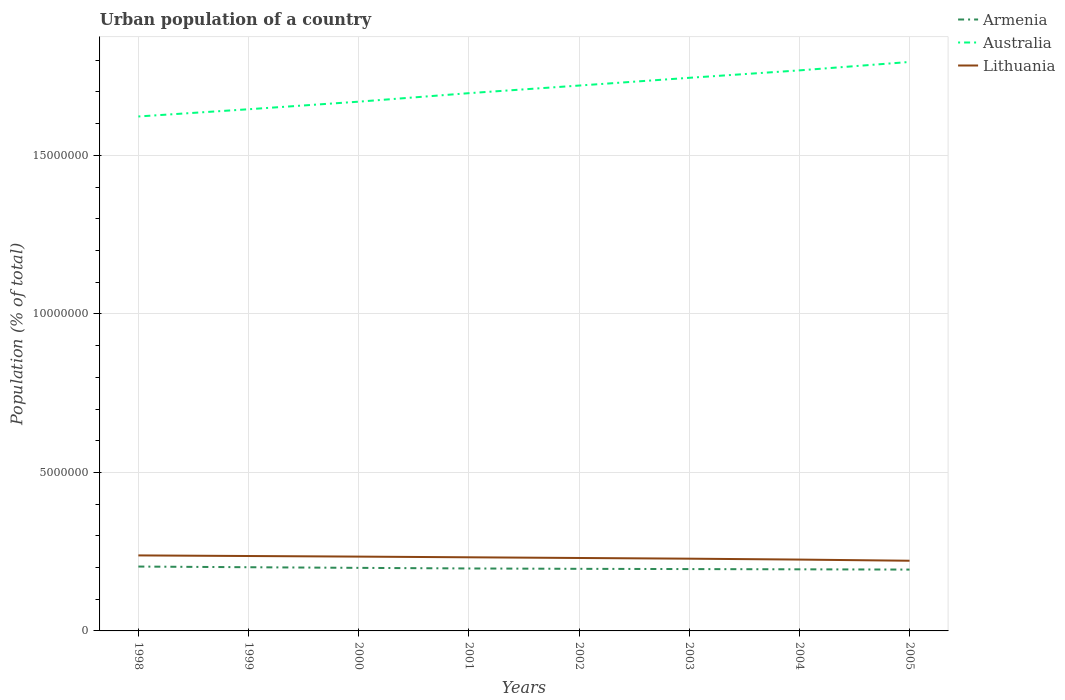Does the line corresponding to Australia intersect with the line corresponding to Armenia?
Keep it short and to the point. No. Is the number of lines equal to the number of legend labels?
Keep it short and to the point. Yes. Across all years, what is the maximum urban population in Armenia?
Offer a terse response. 1.94e+06. What is the total urban population in Lithuania in the graph?
Keep it short and to the point. 4.33e+04. What is the difference between the highest and the second highest urban population in Australia?
Offer a terse response. 1.72e+06. Is the urban population in Armenia strictly greater than the urban population in Lithuania over the years?
Ensure brevity in your answer.  Yes. How many lines are there?
Keep it short and to the point. 3. How many years are there in the graph?
Provide a succinct answer. 8. What is the difference between two consecutive major ticks on the Y-axis?
Provide a succinct answer. 5.00e+06. Where does the legend appear in the graph?
Offer a terse response. Top right. What is the title of the graph?
Keep it short and to the point. Urban population of a country. What is the label or title of the X-axis?
Make the answer very short. Years. What is the label or title of the Y-axis?
Give a very brief answer. Population (% of total). What is the Population (% of total) of Armenia in 1998?
Ensure brevity in your answer.  2.03e+06. What is the Population (% of total) of Australia in 1998?
Offer a very short reply. 1.62e+07. What is the Population (% of total) of Lithuania in 1998?
Ensure brevity in your answer.  2.38e+06. What is the Population (% of total) of Armenia in 1999?
Make the answer very short. 2.01e+06. What is the Population (% of total) in Australia in 1999?
Provide a succinct answer. 1.65e+07. What is the Population (% of total) of Lithuania in 1999?
Your response must be concise. 2.36e+06. What is the Population (% of total) of Armenia in 2000?
Give a very brief answer. 1.99e+06. What is the Population (% of total) of Australia in 2000?
Give a very brief answer. 1.67e+07. What is the Population (% of total) in Lithuania in 2000?
Offer a very short reply. 2.34e+06. What is the Population (% of total) of Armenia in 2001?
Make the answer very short. 1.97e+06. What is the Population (% of total) of Australia in 2001?
Make the answer very short. 1.70e+07. What is the Population (% of total) of Lithuania in 2001?
Your response must be concise. 2.32e+06. What is the Population (% of total) of Armenia in 2002?
Your response must be concise. 1.96e+06. What is the Population (% of total) in Australia in 2002?
Your answer should be very brief. 1.72e+07. What is the Population (% of total) of Lithuania in 2002?
Provide a short and direct response. 2.30e+06. What is the Population (% of total) in Armenia in 2003?
Your answer should be very brief. 1.95e+06. What is the Population (% of total) of Australia in 2003?
Your response must be concise. 1.74e+07. What is the Population (% of total) of Lithuania in 2003?
Your response must be concise. 2.28e+06. What is the Population (% of total) of Armenia in 2004?
Your response must be concise. 1.94e+06. What is the Population (% of total) in Australia in 2004?
Provide a short and direct response. 1.77e+07. What is the Population (% of total) of Lithuania in 2004?
Your response must be concise. 2.25e+06. What is the Population (% of total) in Armenia in 2005?
Your response must be concise. 1.94e+06. What is the Population (% of total) in Australia in 2005?
Offer a very short reply. 1.79e+07. What is the Population (% of total) of Lithuania in 2005?
Your answer should be very brief. 2.21e+06. Across all years, what is the maximum Population (% of total) of Armenia?
Ensure brevity in your answer.  2.03e+06. Across all years, what is the maximum Population (% of total) in Australia?
Give a very brief answer. 1.79e+07. Across all years, what is the maximum Population (% of total) of Lithuania?
Your response must be concise. 2.38e+06. Across all years, what is the minimum Population (% of total) of Armenia?
Keep it short and to the point. 1.94e+06. Across all years, what is the minimum Population (% of total) in Australia?
Your answer should be very brief. 1.62e+07. Across all years, what is the minimum Population (% of total) in Lithuania?
Keep it short and to the point. 2.21e+06. What is the total Population (% of total) of Armenia in the graph?
Give a very brief answer. 1.58e+07. What is the total Population (% of total) in Australia in the graph?
Your answer should be compact. 1.37e+08. What is the total Population (% of total) in Lithuania in the graph?
Your answer should be very brief. 1.85e+07. What is the difference between the Population (% of total) in Armenia in 1998 and that in 1999?
Provide a succinct answer. 2.11e+04. What is the difference between the Population (% of total) in Australia in 1998 and that in 1999?
Provide a short and direct response. -2.28e+05. What is the difference between the Population (% of total) of Lithuania in 1998 and that in 1999?
Your answer should be compact. 1.90e+04. What is the difference between the Population (% of total) of Armenia in 1998 and that in 2000?
Your answer should be very brief. 4.13e+04. What is the difference between the Population (% of total) in Australia in 1998 and that in 2000?
Offer a very short reply. -4.67e+05. What is the difference between the Population (% of total) in Lithuania in 1998 and that in 2000?
Keep it short and to the point. 3.76e+04. What is the difference between the Population (% of total) of Armenia in 1998 and that in 2001?
Ensure brevity in your answer.  6.03e+04. What is the difference between the Population (% of total) of Australia in 1998 and that in 2001?
Offer a very short reply. -7.35e+05. What is the difference between the Population (% of total) in Lithuania in 1998 and that in 2001?
Your answer should be very brief. 5.92e+04. What is the difference between the Population (% of total) of Armenia in 1998 and that in 2002?
Ensure brevity in your answer.  7.16e+04. What is the difference between the Population (% of total) in Australia in 1998 and that in 2002?
Give a very brief answer. -9.76e+05. What is the difference between the Population (% of total) in Lithuania in 1998 and that in 2002?
Your response must be concise. 8.09e+04. What is the difference between the Population (% of total) of Armenia in 1998 and that in 2003?
Provide a short and direct response. 7.96e+04. What is the difference between the Population (% of total) in Australia in 1998 and that in 2003?
Make the answer very short. -1.22e+06. What is the difference between the Population (% of total) in Lithuania in 1998 and that in 2003?
Your response must be concise. 1.03e+05. What is the difference between the Population (% of total) of Armenia in 1998 and that in 2004?
Provide a succinct answer. 8.73e+04. What is the difference between the Population (% of total) of Australia in 1998 and that in 2004?
Provide a succinct answer. -1.45e+06. What is the difference between the Population (% of total) in Lithuania in 1998 and that in 2004?
Your answer should be very brief. 1.31e+05. What is the difference between the Population (% of total) of Armenia in 1998 and that in 2005?
Your answer should be very brief. 9.54e+04. What is the difference between the Population (% of total) of Australia in 1998 and that in 2005?
Provide a succinct answer. -1.72e+06. What is the difference between the Population (% of total) in Lithuania in 1998 and that in 2005?
Give a very brief answer. 1.68e+05. What is the difference between the Population (% of total) in Armenia in 1999 and that in 2000?
Keep it short and to the point. 2.02e+04. What is the difference between the Population (% of total) of Australia in 1999 and that in 2000?
Your answer should be compact. -2.39e+05. What is the difference between the Population (% of total) in Lithuania in 1999 and that in 2000?
Your response must be concise. 1.87e+04. What is the difference between the Population (% of total) in Armenia in 1999 and that in 2001?
Provide a short and direct response. 3.91e+04. What is the difference between the Population (% of total) in Australia in 1999 and that in 2001?
Provide a succinct answer. -5.07e+05. What is the difference between the Population (% of total) of Lithuania in 1999 and that in 2001?
Give a very brief answer. 4.02e+04. What is the difference between the Population (% of total) in Armenia in 1999 and that in 2002?
Ensure brevity in your answer.  5.05e+04. What is the difference between the Population (% of total) of Australia in 1999 and that in 2002?
Make the answer very short. -7.47e+05. What is the difference between the Population (% of total) of Lithuania in 1999 and that in 2002?
Ensure brevity in your answer.  6.19e+04. What is the difference between the Population (% of total) of Armenia in 1999 and that in 2003?
Make the answer very short. 5.84e+04. What is the difference between the Population (% of total) of Australia in 1999 and that in 2003?
Keep it short and to the point. -9.92e+05. What is the difference between the Population (% of total) of Lithuania in 1999 and that in 2003?
Your response must be concise. 8.36e+04. What is the difference between the Population (% of total) of Armenia in 1999 and that in 2004?
Provide a short and direct response. 6.61e+04. What is the difference between the Population (% of total) of Australia in 1999 and that in 2004?
Ensure brevity in your answer.  -1.23e+06. What is the difference between the Population (% of total) of Lithuania in 1999 and that in 2004?
Offer a very short reply. 1.12e+05. What is the difference between the Population (% of total) of Armenia in 1999 and that in 2005?
Make the answer very short. 7.42e+04. What is the difference between the Population (% of total) of Australia in 1999 and that in 2005?
Ensure brevity in your answer.  -1.49e+06. What is the difference between the Population (% of total) of Lithuania in 1999 and that in 2005?
Your response must be concise. 1.49e+05. What is the difference between the Population (% of total) in Armenia in 2000 and that in 2001?
Give a very brief answer. 1.90e+04. What is the difference between the Population (% of total) in Australia in 2000 and that in 2001?
Offer a terse response. -2.68e+05. What is the difference between the Population (% of total) of Lithuania in 2000 and that in 2001?
Ensure brevity in your answer.  2.16e+04. What is the difference between the Population (% of total) of Armenia in 2000 and that in 2002?
Keep it short and to the point. 3.03e+04. What is the difference between the Population (% of total) in Australia in 2000 and that in 2002?
Your answer should be compact. -5.08e+05. What is the difference between the Population (% of total) of Lithuania in 2000 and that in 2002?
Your response must be concise. 4.33e+04. What is the difference between the Population (% of total) in Armenia in 2000 and that in 2003?
Keep it short and to the point. 3.83e+04. What is the difference between the Population (% of total) of Australia in 2000 and that in 2003?
Offer a very short reply. -7.53e+05. What is the difference between the Population (% of total) in Lithuania in 2000 and that in 2003?
Make the answer very short. 6.50e+04. What is the difference between the Population (% of total) in Armenia in 2000 and that in 2004?
Offer a very short reply. 4.60e+04. What is the difference between the Population (% of total) of Australia in 2000 and that in 2004?
Keep it short and to the point. -9.87e+05. What is the difference between the Population (% of total) in Lithuania in 2000 and that in 2004?
Make the answer very short. 9.35e+04. What is the difference between the Population (% of total) of Armenia in 2000 and that in 2005?
Make the answer very short. 5.41e+04. What is the difference between the Population (% of total) in Australia in 2000 and that in 2005?
Give a very brief answer. -1.25e+06. What is the difference between the Population (% of total) in Lithuania in 2000 and that in 2005?
Make the answer very short. 1.30e+05. What is the difference between the Population (% of total) in Armenia in 2001 and that in 2002?
Provide a short and direct response. 1.13e+04. What is the difference between the Population (% of total) of Australia in 2001 and that in 2002?
Your answer should be compact. -2.40e+05. What is the difference between the Population (% of total) in Lithuania in 2001 and that in 2002?
Your answer should be very brief. 2.17e+04. What is the difference between the Population (% of total) of Armenia in 2001 and that in 2003?
Provide a succinct answer. 1.93e+04. What is the difference between the Population (% of total) in Australia in 2001 and that in 2003?
Your answer should be compact. -4.85e+05. What is the difference between the Population (% of total) of Lithuania in 2001 and that in 2003?
Your response must be concise. 4.34e+04. What is the difference between the Population (% of total) of Armenia in 2001 and that in 2004?
Ensure brevity in your answer.  2.70e+04. What is the difference between the Population (% of total) in Australia in 2001 and that in 2004?
Your answer should be very brief. -7.19e+05. What is the difference between the Population (% of total) of Lithuania in 2001 and that in 2004?
Make the answer very short. 7.20e+04. What is the difference between the Population (% of total) in Armenia in 2001 and that in 2005?
Your answer should be compact. 3.51e+04. What is the difference between the Population (% of total) of Australia in 2001 and that in 2005?
Make the answer very short. -9.85e+05. What is the difference between the Population (% of total) of Lithuania in 2001 and that in 2005?
Keep it short and to the point. 1.09e+05. What is the difference between the Population (% of total) of Armenia in 2002 and that in 2003?
Provide a succinct answer. 7963. What is the difference between the Population (% of total) in Australia in 2002 and that in 2003?
Provide a succinct answer. -2.44e+05. What is the difference between the Population (% of total) in Lithuania in 2002 and that in 2003?
Offer a terse response. 2.17e+04. What is the difference between the Population (% of total) of Armenia in 2002 and that in 2004?
Offer a very short reply. 1.57e+04. What is the difference between the Population (% of total) of Australia in 2002 and that in 2004?
Make the answer very short. -4.79e+05. What is the difference between the Population (% of total) of Lithuania in 2002 and that in 2004?
Ensure brevity in your answer.  5.02e+04. What is the difference between the Population (% of total) in Armenia in 2002 and that in 2005?
Offer a terse response. 2.38e+04. What is the difference between the Population (% of total) in Australia in 2002 and that in 2005?
Keep it short and to the point. -7.44e+05. What is the difference between the Population (% of total) in Lithuania in 2002 and that in 2005?
Offer a very short reply. 8.70e+04. What is the difference between the Population (% of total) of Armenia in 2003 and that in 2004?
Ensure brevity in your answer.  7705. What is the difference between the Population (% of total) of Australia in 2003 and that in 2004?
Your answer should be very brief. -2.34e+05. What is the difference between the Population (% of total) in Lithuania in 2003 and that in 2004?
Make the answer very short. 2.85e+04. What is the difference between the Population (% of total) in Armenia in 2003 and that in 2005?
Your response must be concise. 1.58e+04. What is the difference between the Population (% of total) of Australia in 2003 and that in 2005?
Your response must be concise. -5.00e+05. What is the difference between the Population (% of total) in Lithuania in 2003 and that in 2005?
Give a very brief answer. 6.52e+04. What is the difference between the Population (% of total) in Armenia in 2004 and that in 2005?
Your answer should be compact. 8101. What is the difference between the Population (% of total) in Australia in 2004 and that in 2005?
Offer a terse response. -2.66e+05. What is the difference between the Population (% of total) of Lithuania in 2004 and that in 2005?
Keep it short and to the point. 3.67e+04. What is the difference between the Population (% of total) in Armenia in 1998 and the Population (% of total) in Australia in 1999?
Provide a succinct answer. -1.44e+07. What is the difference between the Population (% of total) of Armenia in 1998 and the Population (% of total) of Lithuania in 1999?
Ensure brevity in your answer.  -3.32e+05. What is the difference between the Population (% of total) in Australia in 1998 and the Population (% of total) in Lithuania in 1999?
Your answer should be compact. 1.39e+07. What is the difference between the Population (% of total) of Armenia in 1998 and the Population (% of total) of Australia in 2000?
Offer a terse response. -1.47e+07. What is the difference between the Population (% of total) in Armenia in 1998 and the Population (% of total) in Lithuania in 2000?
Make the answer very short. -3.14e+05. What is the difference between the Population (% of total) of Australia in 1998 and the Population (% of total) of Lithuania in 2000?
Keep it short and to the point. 1.39e+07. What is the difference between the Population (% of total) of Armenia in 1998 and the Population (% of total) of Australia in 2001?
Offer a terse response. -1.49e+07. What is the difference between the Population (% of total) in Armenia in 1998 and the Population (% of total) in Lithuania in 2001?
Provide a short and direct response. -2.92e+05. What is the difference between the Population (% of total) in Australia in 1998 and the Population (% of total) in Lithuania in 2001?
Your answer should be compact. 1.39e+07. What is the difference between the Population (% of total) in Armenia in 1998 and the Population (% of total) in Australia in 2002?
Make the answer very short. -1.52e+07. What is the difference between the Population (% of total) of Armenia in 1998 and the Population (% of total) of Lithuania in 2002?
Your response must be concise. -2.70e+05. What is the difference between the Population (% of total) of Australia in 1998 and the Population (% of total) of Lithuania in 2002?
Ensure brevity in your answer.  1.39e+07. What is the difference between the Population (% of total) in Armenia in 1998 and the Population (% of total) in Australia in 2003?
Your answer should be very brief. -1.54e+07. What is the difference between the Population (% of total) of Armenia in 1998 and the Population (% of total) of Lithuania in 2003?
Keep it short and to the point. -2.49e+05. What is the difference between the Population (% of total) of Australia in 1998 and the Population (% of total) of Lithuania in 2003?
Your response must be concise. 1.39e+07. What is the difference between the Population (% of total) of Armenia in 1998 and the Population (% of total) of Australia in 2004?
Your answer should be compact. -1.57e+07. What is the difference between the Population (% of total) in Armenia in 1998 and the Population (% of total) in Lithuania in 2004?
Make the answer very short. -2.20e+05. What is the difference between the Population (% of total) in Australia in 1998 and the Population (% of total) in Lithuania in 2004?
Your answer should be very brief. 1.40e+07. What is the difference between the Population (% of total) in Armenia in 1998 and the Population (% of total) in Australia in 2005?
Provide a short and direct response. -1.59e+07. What is the difference between the Population (% of total) in Armenia in 1998 and the Population (% of total) in Lithuania in 2005?
Offer a terse response. -1.84e+05. What is the difference between the Population (% of total) in Australia in 1998 and the Population (% of total) in Lithuania in 2005?
Provide a short and direct response. 1.40e+07. What is the difference between the Population (% of total) of Armenia in 1999 and the Population (% of total) of Australia in 2000?
Your response must be concise. -1.47e+07. What is the difference between the Population (% of total) of Armenia in 1999 and the Population (% of total) of Lithuania in 2000?
Make the answer very short. -3.35e+05. What is the difference between the Population (% of total) in Australia in 1999 and the Population (% of total) in Lithuania in 2000?
Make the answer very short. 1.41e+07. What is the difference between the Population (% of total) of Armenia in 1999 and the Population (% of total) of Australia in 2001?
Offer a terse response. -1.50e+07. What is the difference between the Population (% of total) of Armenia in 1999 and the Population (% of total) of Lithuania in 2001?
Make the answer very short. -3.13e+05. What is the difference between the Population (% of total) in Australia in 1999 and the Population (% of total) in Lithuania in 2001?
Make the answer very short. 1.41e+07. What is the difference between the Population (% of total) in Armenia in 1999 and the Population (% of total) in Australia in 2002?
Your answer should be very brief. -1.52e+07. What is the difference between the Population (% of total) of Armenia in 1999 and the Population (% of total) of Lithuania in 2002?
Give a very brief answer. -2.92e+05. What is the difference between the Population (% of total) of Australia in 1999 and the Population (% of total) of Lithuania in 2002?
Make the answer very short. 1.42e+07. What is the difference between the Population (% of total) of Armenia in 1999 and the Population (% of total) of Australia in 2003?
Ensure brevity in your answer.  -1.54e+07. What is the difference between the Population (% of total) in Armenia in 1999 and the Population (% of total) in Lithuania in 2003?
Keep it short and to the point. -2.70e+05. What is the difference between the Population (% of total) in Australia in 1999 and the Population (% of total) in Lithuania in 2003?
Your answer should be compact. 1.42e+07. What is the difference between the Population (% of total) of Armenia in 1999 and the Population (% of total) of Australia in 2004?
Your answer should be very brief. -1.57e+07. What is the difference between the Population (% of total) of Armenia in 1999 and the Population (% of total) of Lithuania in 2004?
Provide a short and direct response. -2.41e+05. What is the difference between the Population (% of total) of Australia in 1999 and the Population (% of total) of Lithuania in 2004?
Offer a terse response. 1.42e+07. What is the difference between the Population (% of total) in Armenia in 1999 and the Population (% of total) in Australia in 2005?
Provide a short and direct response. -1.59e+07. What is the difference between the Population (% of total) in Armenia in 1999 and the Population (% of total) in Lithuania in 2005?
Your answer should be very brief. -2.05e+05. What is the difference between the Population (% of total) in Australia in 1999 and the Population (% of total) in Lithuania in 2005?
Offer a very short reply. 1.42e+07. What is the difference between the Population (% of total) in Armenia in 2000 and the Population (% of total) in Australia in 2001?
Give a very brief answer. -1.50e+07. What is the difference between the Population (% of total) in Armenia in 2000 and the Population (% of total) in Lithuania in 2001?
Offer a terse response. -3.33e+05. What is the difference between the Population (% of total) in Australia in 2000 and the Population (% of total) in Lithuania in 2001?
Give a very brief answer. 1.44e+07. What is the difference between the Population (% of total) in Armenia in 2000 and the Population (% of total) in Australia in 2002?
Offer a terse response. -1.52e+07. What is the difference between the Population (% of total) of Armenia in 2000 and the Population (% of total) of Lithuania in 2002?
Give a very brief answer. -3.12e+05. What is the difference between the Population (% of total) of Australia in 2000 and the Population (% of total) of Lithuania in 2002?
Your answer should be very brief. 1.44e+07. What is the difference between the Population (% of total) of Armenia in 2000 and the Population (% of total) of Australia in 2003?
Ensure brevity in your answer.  -1.55e+07. What is the difference between the Population (% of total) in Armenia in 2000 and the Population (% of total) in Lithuania in 2003?
Make the answer very short. -2.90e+05. What is the difference between the Population (% of total) in Australia in 2000 and the Population (% of total) in Lithuania in 2003?
Offer a very short reply. 1.44e+07. What is the difference between the Population (% of total) in Armenia in 2000 and the Population (% of total) in Australia in 2004?
Provide a succinct answer. -1.57e+07. What is the difference between the Population (% of total) of Armenia in 2000 and the Population (% of total) of Lithuania in 2004?
Your answer should be compact. -2.61e+05. What is the difference between the Population (% of total) of Australia in 2000 and the Population (% of total) of Lithuania in 2004?
Ensure brevity in your answer.  1.44e+07. What is the difference between the Population (% of total) of Armenia in 2000 and the Population (% of total) of Australia in 2005?
Keep it short and to the point. -1.60e+07. What is the difference between the Population (% of total) of Armenia in 2000 and the Population (% of total) of Lithuania in 2005?
Your response must be concise. -2.25e+05. What is the difference between the Population (% of total) of Australia in 2000 and the Population (% of total) of Lithuania in 2005?
Keep it short and to the point. 1.45e+07. What is the difference between the Population (% of total) of Armenia in 2001 and the Population (% of total) of Australia in 2002?
Offer a very short reply. -1.52e+07. What is the difference between the Population (% of total) in Armenia in 2001 and the Population (% of total) in Lithuania in 2002?
Provide a succinct answer. -3.31e+05. What is the difference between the Population (% of total) of Australia in 2001 and the Population (% of total) of Lithuania in 2002?
Offer a terse response. 1.47e+07. What is the difference between the Population (% of total) of Armenia in 2001 and the Population (% of total) of Australia in 2003?
Your answer should be compact. -1.55e+07. What is the difference between the Population (% of total) in Armenia in 2001 and the Population (% of total) in Lithuania in 2003?
Your response must be concise. -3.09e+05. What is the difference between the Population (% of total) of Australia in 2001 and the Population (% of total) of Lithuania in 2003?
Keep it short and to the point. 1.47e+07. What is the difference between the Population (% of total) in Armenia in 2001 and the Population (% of total) in Australia in 2004?
Provide a succinct answer. -1.57e+07. What is the difference between the Population (% of total) of Armenia in 2001 and the Population (% of total) of Lithuania in 2004?
Offer a very short reply. -2.80e+05. What is the difference between the Population (% of total) of Australia in 2001 and the Population (% of total) of Lithuania in 2004?
Offer a terse response. 1.47e+07. What is the difference between the Population (% of total) of Armenia in 2001 and the Population (% of total) of Australia in 2005?
Give a very brief answer. -1.60e+07. What is the difference between the Population (% of total) in Armenia in 2001 and the Population (% of total) in Lithuania in 2005?
Your response must be concise. -2.44e+05. What is the difference between the Population (% of total) of Australia in 2001 and the Population (% of total) of Lithuania in 2005?
Give a very brief answer. 1.47e+07. What is the difference between the Population (% of total) in Armenia in 2002 and the Population (% of total) in Australia in 2003?
Give a very brief answer. -1.55e+07. What is the difference between the Population (% of total) in Armenia in 2002 and the Population (% of total) in Lithuania in 2003?
Provide a short and direct response. -3.20e+05. What is the difference between the Population (% of total) of Australia in 2002 and the Population (% of total) of Lithuania in 2003?
Your response must be concise. 1.49e+07. What is the difference between the Population (% of total) in Armenia in 2002 and the Population (% of total) in Australia in 2004?
Your answer should be compact. -1.57e+07. What is the difference between the Population (% of total) in Armenia in 2002 and the Population (% of total) in Lithuania in 2004?
Your answer should be compact. -2.92e+05. What is the difference between the Population (% of total) in Australia in 2002 and the Population (% of total) in Lithuania in 2004?
Provide a succinct answer. 1.50e+07. What is the difference between the Population (% of total) in Armenia in 2002 and the Population (% of total) in Australia in 2005?
Give a very brief answer. -1.60e+07. What is the difference between the Population (% of total) in Armenia in 2002 and the Population (% of total) in Lithuania in 2005?
Give a very brief answer. -2.55e+05. What is the difference between the Population (% of total) of Australia in 2002 and the Population (% of total) of Lithuania in 2005?
Ensure brevity in your answer.  1.50e+07. What is the difference between the Population (% of total) in Armenia in 2003 and the Population (% of total) in Australia in 2004?
Your answer should be very brief. -1.57e+07. What is the difference between the Population (% of total) in Armenia in 2003 and the Population (% of total) in Lithuania in 2004?
Offer a very short reply. -3.00e+05. What is the difference between the Population (% of total) in Australia in 2003 and the Population (% of total) in Lithuania in 2004?
Make the answer very short. 1.52e+07. What is the difference between the Population (% of total) in Armenia in 2003 and the Population (% of total) in Australia in 2005?
Offer a terse response. -1.60e+07. What is the difference between the Population (% of total) of Armenia in 2003 and the Population (% of total) of Lithuania in 2005?
Your answer should be compact. -2.63e+05. What is the difference between the Population (% of total) in Australia in 2003 and the Population (% of total) in Lithuania in 2005?
Provide a succinct answer. 1.52e+07. What is the difference between the Population (% of total) of Armenia in 2004 and the Population (% of total) of Australia in 2005?
Offer a very short reply. -1.60e+07. What is the difference between the Population (% of total) of Armenia in 2004 and the Population (% of total) of Lithuania in 2005?
Ensure brevity in your answer.  -2.71e+05. What is the difference between the Population (% of total) in Australia in 2004 and the Population (% of total) in Lithuania in 2005?
Offer a very short reply. 1.55e+07. What is the average Population (% of total) in Armenia per year?
Ensure brevity in your answer.  1.97e+06. What is the average Population (% of total) of Australia per year?
Your answer should be very brief. 1.71e+07. What is the average Population (% of total) in Lithuania per year?
Keep it short and to the point. 2.31e+06. In the year 1998, what is the difference between the Population (% of total) of Armenia and Population (% of total) of Australia?
Your response must be concise. -1.42e+07. In the year 1998, what is the difference between the Population (% of total) of Armenia and Population (% of total) of Lithuania?
Provide a short and direct response. -3.51e+05. In the year 1998, what is the difference between the Population (% of total) in Australia and Population (% of total) in Lithuania?
Your answer should be compact. 1.38e+07. In the year 1999, what is the difference between the Population (% of total) of Armenia and Population (% of total) of Australia?
Your response must be concise. -1.44e+07. In the year 1999, what is the difference between the Population (% of total) of Armenia and Population (% of total) of Lithuania?
Make the answer very short. -3.54e+05. In the year 1999, what is the difference between the Population (% of total) of Australia and Population (% of total) of Lithuania?
Your answer should be compact. 1.41e+07. In the year 2000, what is the difference between the Population (% of total) of Armenia and Population (% of total) of Australia?
Offer a very short reply. -1.47e+07. In the year 2000, what is the difference between the Population (% of total) of Armenia and Population (% of total) of Lithuania?
Keep it short and to the point. -3.55e+05. In the year 2000, what is the difference between the Population (% of total) of Australia and Population (% of total) of Lithuania?
Your answer should be compact. 1.44e+07. In the year 2001, what is the difference between the Population (% of total) in Armenia and Population (% of total) in Australia?
Offer a terse response. -1.50e+07. In the year 2001, what is the difference between the Population (% of total) in Armenia and Population (% of total) in Lithuania?
Your answer should be very brief. -3.52e+05. In the year 2001, what is the difference between the Population (% of total) in Australia and Population (% of total) in Lithuania?
Your response must be concise. 1.46e+07. In the year 2002, what is the difference between the Population (% of total) of Armenia and Population (% of total) of Australia?
Give a very brief answer. -1.52e+07. In the year 2002, what is the difference between the Population (% of total) in Armenia and Population (% of total) in Lithuania?
Keep it short and to the point. -3.42e+05. In the year 2002, what is the difference between the Population (% of total) of Australia and Population (% of total) of Lithuania?
Make the answer very short. 1.49e+07. In the year 2003, what is the difference between the Population (% of total) in Armenia and Population (% of total) in Australia?
Your answer should be compact. -1.55e+07. In the year 2003, what is the difference between the Population (% of total) of Armenia and Population (% of total) of Lithuania?
Your response must be concise. -3.28e+05. In the year 2003, what is the difference between the Population (% of total) of Australia and Population (% of total) of Lithuania?
Offer a terse response. 1.52e+07. In the year 2004, what is the difference between the Population (% of total) of Armenia and Population (% of total) of Australia?
Make the answer very short. -1.57e+07. In the year 2004, what is the difference between the Population (% of total) in Armenia and Population (% of total) in Lithuania?
Make the answer very short. -3.07e+05. In the year 2004, what is the difference between the Population (% of total) in Australia and Population (% of total) in Lithuania?
Your answer should be compact. 1.54e+07. In the year 2005, what is the difference between the Population (% of total) of Armenia and Population (% of total) of Australia?
Your answer should be very brief. -1.60e+07. In the year 2005, what is the difference between the Population (% of total) in Armenia and Population (% of total) in Lithuania?
Ensure brevity in your answer.  -2.79e+05. In the year 2005, what is the difference between the Population (% of total) in Australia and Population (% of total) in Lithuania?
Offer a terse response. 1.57e+07. What is the ratio of the Population (% of total) in Armenia in 1998 to that in 1999?
Ensure brevity in your answer.  1.01. What is the ratio of the Population (% of total) in Australia in 1998 to that in 1999?
Offer a terse response. 0.99. What is the ratio of the Population (% of total) of Lithuania in 1998 to that in 1999?
Your answer should be compact. 1.01. What is the ratio of the Population (% of total) of Armenia in 1998 to that in 2000?
Keep it short and to the point. 1.02. What is the ratio of the Population (% of total) in Australia in 1998 to that in 2000?
Your response must be concise. 0.97. What is the ratio of the Population (% of total) in Lithuania in 1998 to that in 2000?
Keep it short and to the point. 1.02. What is the ratio of the Population (% of total) of Armenia in 1998 to that in 2001?
Your answer should be compact. 1.03. What is the ratio of the Population (% of total) in Australia in 1998 to that in 2001?
Keep it short and to the point. 0.96. What is the ratio of the Population (% of total) of Lithuania in 1998 to that in 2001?
Your response must be concise. 1.03. What is the ratio of the Population (% of total) of Armenia in 1998 to that in 2002?
Provide a short and direct response. 1.04. What is the ratio of the Population (% of total) in Australia in 1998 to that in 2002?
Offer a very short reply. 0.94. What is the ratio of the Population (% of total) of Lithuania in 1998 to that in 2002?
Give a very brief answer. 1.04. What is the ratio of the Population (% of total) in Armenia in 1998 to that in 2003?
Provide a short and direct response. 1.04. What is the ratio of the Population (% of total) in Australia in 1998 to that in 2003?
Your response must be concise. 0.93. What is the ratio of the Population (% of total) of Lithuania in 1998 to that in 2003?
Your response must be concise. 1.04. What is the ratio of the Population (% of total) of Armenia in 1998 to that in 2004?
Your response must be concise. 1.04. What is the ratio of the Population (% of total) of Australia in 1998 to that in 2004?
Offer a very short reply. 0.92. What is the ratio of the Population (% of total) in Lithuania in 1998 to that in 2004?
Your answer should be compact. 1.06. What is the ratio of the Population (% of total) of Armenia in 1998 to that in 2005?
Make the answer very short. 1.05. What is the ratio of the Population (% of total) of Australia in 1998 to that in 2005?
Make the answer very short. 0.9. What is the ratio of the Population (% of total) of Lithuania in 1998 to that in 2005?
Provide a succinct answer. 1.08. What is the ratio of the Population (% of total) in Australia in 1999 to that in 2000?
Your answer should be compact. 0.99. What is the ratio of the Population (% of total) of Armenia in 1999 to that in 2001?
Provide a short and direct response. 1.02. What is the ratio of the Population (% of total) in Australia in 1999 to that in 2001?
Provide a succinct answer. 0.97. What is the ratio of the Population (% of total) of Lithuania in 1999 to that in 2001?
Provide a short and direct response. 1.02. What is the ratio of the Population (% of total) in Armenia in 1999 to that in 2002?
Provide a short and direct response. 1.03. What is the ratio of the Population (% of total) in Australia in 1999 to that in 2002?
Your answer should be compact. 0.96. What is the ratio of the Population (% of total) in Lithuania in 1999 to that in 2002?
Make the answer very short. 1.03. What is the ratio of the Population (% of total) of Armenia in 1999 to that in 2003?
Offer a very short reply. 1.03. What is the ratio of the Population (% of total) in Australia in 1999 to that in 2003?
Your answer should be very brief. 0.94. What is the ratio of the Population (% of total) in Lithuania in 1999 to that in 2003?
Give a very brief answer. 1.04. What is the ratio of the Population (% of total) in Armenia in 1999 to that in 2004?
Ensure brevity in your answer.  1.03. What is the ratio of the Population (% of total) of Australia in 1999 to that in 2004?
Your answer should be compact. 0.93. What is the ratio of the Population (% of total) in Lithuania in 1999 to that in 2004?
Offer a terse response. 1.05. What is the ratio of the Population (% of total) of Armenia in 1999 to that in 2005?
Offer a terse response. 1.04. What is the ratio of the Population (% of total) of Australia in 1999 to that in 2005?
Give a very brief answer. 0.92. What is the ratio of the Population (% of total) of Lithuania in 1999 to that in 2005?
Offer a very short reply. 1.07. What is the ratio of the Population (% of total) of Armenia in 2000 to that in 2001?
Offer a terse response. 1.01. What is the ratio of the Population (% of total) of Australia in 2000 to that in 2001?
Offer a terse response. 0.98. What is the ratio of the Population (% of total) of Lithuania in 2000 to that in 2001?
Make the answer very short. 1.01. What is the ratio of the Population (% of total) in Armenia in 2000 to that in 2002?
Keep it short and to the point. 1.02. What is the ratio of the Population (% of total) in Australia in 2000 to that in 2002?
Provide a short and direct response. 0.97. What is the ratio of the Population (% of total) in Lithuania in 2000 to that in 2002?
Give a very brief answer. 1.02. What is the ratio of the Population (% of total) in Armenia in 2000 to that in 2003?
Your response must be concise. 1.02. What is the ratio of the Population (% of total) of Australia in 2000 to that in 2003?
Offer a terse response. 0.96. What is the ratio of the Population (% of total) of Lithuania in 2000 to that in 2003?
Provide a short and direct response. 1.03. What is the ratio of the Population (% of total) of Armenia in 2000 to that in 2004?
Your response must be concise. 1.02. What is the ratio of the Population (% of total) in Australia in 2000 to that in 2004?
Provide a short and direct response. 0.94. What is the ratio of the Population (% of total) in Lithuania in 2000 to that in 2004?
Ensure brevity in your answer.  1.04. What is the ratio of the Population (% of total) in Armenia in 2000 to that in 2005?
Provide a short and direct response. 1.03. What is the ratio of the Population (% of total) of Australia in 2000 to that in 2005?
Offer a terse response. 0.93. What is the ratio of the Population (% of total) of Lithuania in 2000 to that in 2005?
Offer a very short reply. 1.06. What is the ratio of the Population (% of total) of Armenia in 2001 to that in 2002?
Offer a very short reply. 1.01. What is the ratio of the Population (% of total) in Australia in 2001 to that in 2002?
Offer a very short reply. 0.99. What is the ratio of the Population (% of total) in Lithuania in 2001 to that in 2002?
Your answer should be compact. 1.01. What is the ratio of the Population (% of total) of Armenia in 2001 to that in 2003?
Offer a terse response. 1.01. What is the ratio of the Population (% of total) of Australia in 2001 to that in 2003?
Your response must be concise. 0.97. What is the ratio of the Population (% of total) of Lithuania in 2001 to that in 2003?
Keep it short and to the point. 1.02. What is the ratio of the Population (% of total) of Armenia in 2001 to that in 2004?
Keep it short and to the point. 1.01. What is the ratio of the Population (% of total) of Australia in 2001 to that in 2004?
Provide a short and direct response. 0.96. What is the ratio of the Population (% of total) in Lithuania in 2001 to that in 2004?
Offer a very short reply. 1.03. What is the ratio of the Population (% of total) in Armenia in 2001 to that in 2005?
Your answer should be very brief. 1.02. What is the ratio of the Population (% of total) of Australia in 2001 to that in 2005?
Make the answer very short. 0.95. What is the ratio of the Population (% of total) in Lithuania in 2001 to that in 2005?
Keep it short and to the point. 1.05. What is the ratio of the Population (% of total) of Armenia in 2002 to that in 2003?
Offer a very short reply. 1. What is the ratio of the Population (% of total) in Lithuania in 2002 to that in 2003?
Make the answer very short. 1.01. What is the ratio of the Population (% of total) in Armenia in 2002 to that in 2004?
Your response must be concise. 1.01. What is the ratio of the Population (% of total) in Australia in 2002 to that in 2004?
Give a very brief answer. 0.97. What is the ratio of the Population (% of total) of Lithuania in 2002 to that in 2004?
Offer a terse response. 1.02. What is the ratio of the Population (% of total) of Armenia in 2002 to that in 2005?
Keep it short and to the point. 1.01. What is the ratio of the Population (% of total) in Australia in 2002 to that in 2005?
Offer a terse response. 0.96. What is the ratio of the Population (% of total) of Lithuania in 2002 to that in 2005?
Keep it short and to the point. 1.04. What is the ratio of the Population (% of total) of Australia in 2003 to that in 2004?
Your response must be concise. 0.99. What is the ratio of the Population (% of total) in Lithuania in 2003 to that in 2004?
Make the answer very short. 1.01. What is the ratio of the Population (% of total) of Armenia in 2003 to that in 2005?
Keep it short and to the point. 1.01. What is the ratio of the Population (% of total) of Australia in 2003 to that in 2005?
Give a very brief answer. 0.97. What is the ratio of the Population (% of total) in Lithuania in 2003 to that in 2005?
Give a very brief answer. 1.03. What is the ratio of the Population (% of total) of Australia in 2004 to that in 2005?
Offer a very short reply. 0.99. What is the ratio of the Population (% of total) of Lithuania in 2004 to that in 2005?
Provide a short and direct response. 1.02. What is the difference between the highest and the second highest Population (% of total) of Armenia?
Your answer should be very brief. 2.11e+04. What is the difference between the highest and the second highest Population (% of total) in Australia?
Ensure brevity in your answer.  2.66e+05. What is the difference between the highest and the second highest Population (% of total) of Lithuania?
Give a very brief answer. 1.90e+04. What is the difference between the highest and the lowest Population (% of total) in Armenia?
Offer a very short reply. 9.54e+04. What is the difference between the highest and the lowest Population (% of total) in Australia?
Provide a succinct answer. 1.72e+06. What is the difference between the highest and the lowest Population (% of total) in Lithuania?
Your response must be concise. 1.68e+05. 